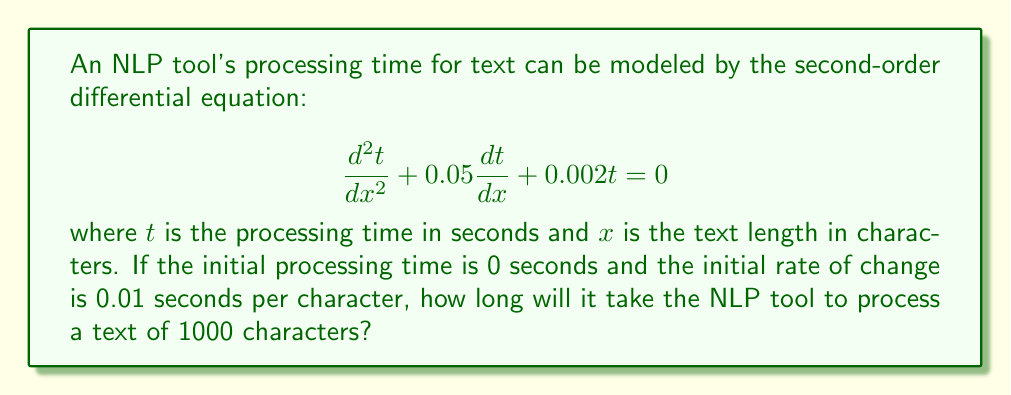What is the answer to this math problem? To solve this problem, we need to follow these steps:

1) The general solution for this second-order linear equation is:

   $$t(x) = c_1e^{r_1x} + c_2e^{r_2x}$$

   where $r_1$ and $r_2$ are the roots of the characteristic equation:

   $$r^2 + 0.05r + 0.002 = 0$$

2) Solving the characteristic equation:

   $$r = \frac{-0.05 \pm \sqrt{0.05^2 - 4(0.002)}}{2} = -0.025 \pm 0.0433i$$

3) Therefore, the general solution is:

   $$t(x) = e^{-0.025x}(c_1\cos(0.0433x) + c_2\sin(0.0433x))$$

4) We need to use the initial conditions to find $c_1$ and $c_2$:

   At $x=0$, $t(0) = 0$, so $c_1 = 0$
   
   At $x=0$, $\frac{dt}{dx}(0) = 0.01$, so $-0.025c_2 + 0.0433c_2 = 0.01$

5) Solving for $c_2$:

   $$c_2 = \frac{0.01}{0.0183} \approx 0.5464$$

6) Our particular solution is:

   $$t(x) = 0.5464e^{-0.025x}\sin(0.0433x)$$

7) To find the time for 1000 characters, we evaluate $t(1000)$:

   $$t(1000) = 0.5464e^{-25}\sin(43.3) \approx 0.2839$$
Answer: The NLP tool will take approximately 0.2839 seconds to process a text of 1000 characters. 